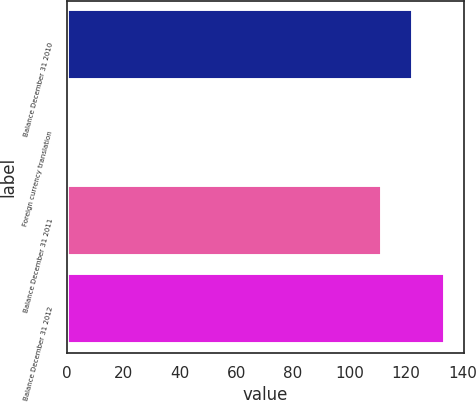<chart> <loc_0><loc_0><loc_500><loc_500><bar_chart><fcel>Balance December 31 2010<fcel>Foreign currency translation<fcel>Balance December 31 2011<fcel>Balance December 31 2012<nl><fcel>122.65<fcel>1<fcel>111.5<fcel>133.8<nl></chart> 